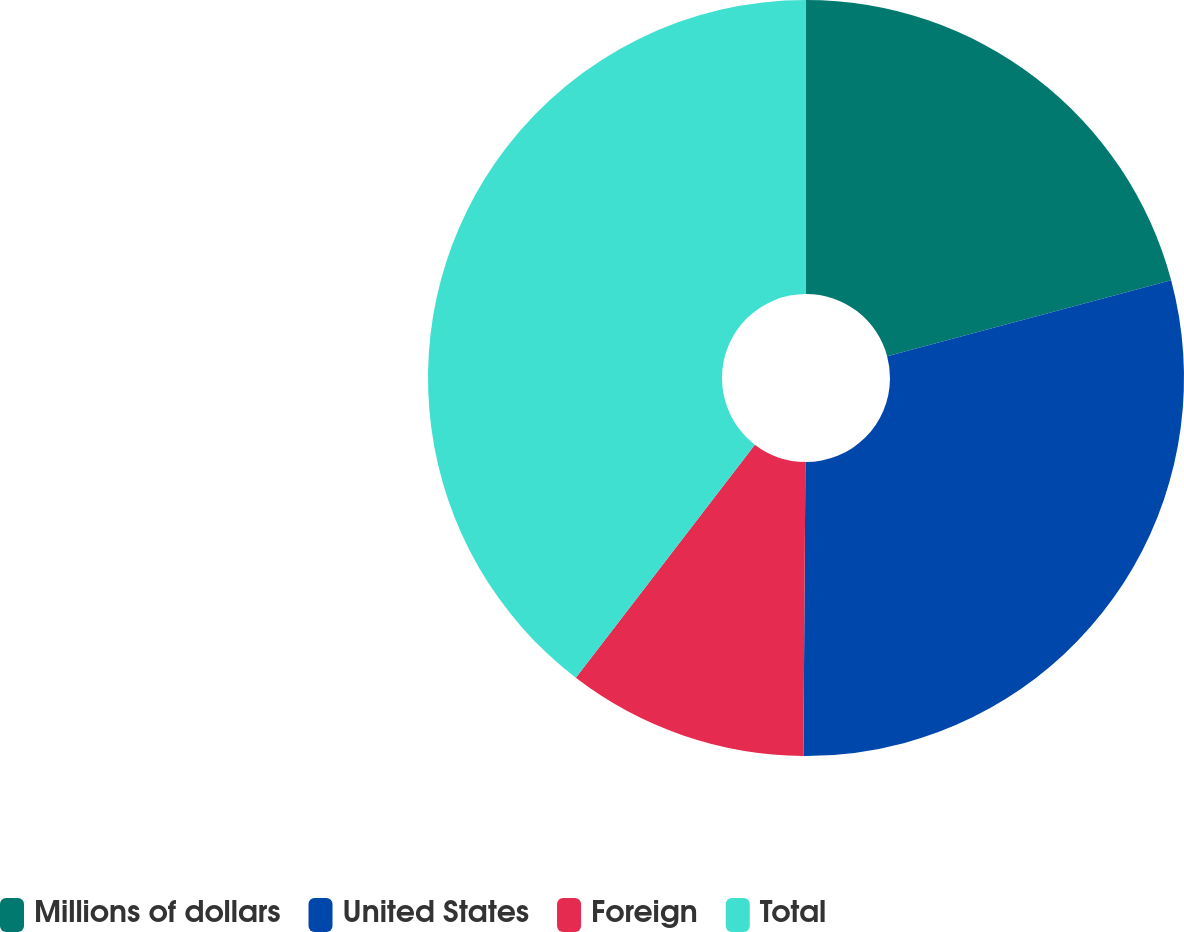Convert chart to OTSL. <chart><loc_0><loc_0><loc_500><loc_500><pie_chart><fcel>Millions of dollars<fcel>United States<fcel>Foreign<fcel>Total<nl><fcel>20.84%<fcel>29.27%<fcel>10.31%<fcel>39.58%<nl></chart> 